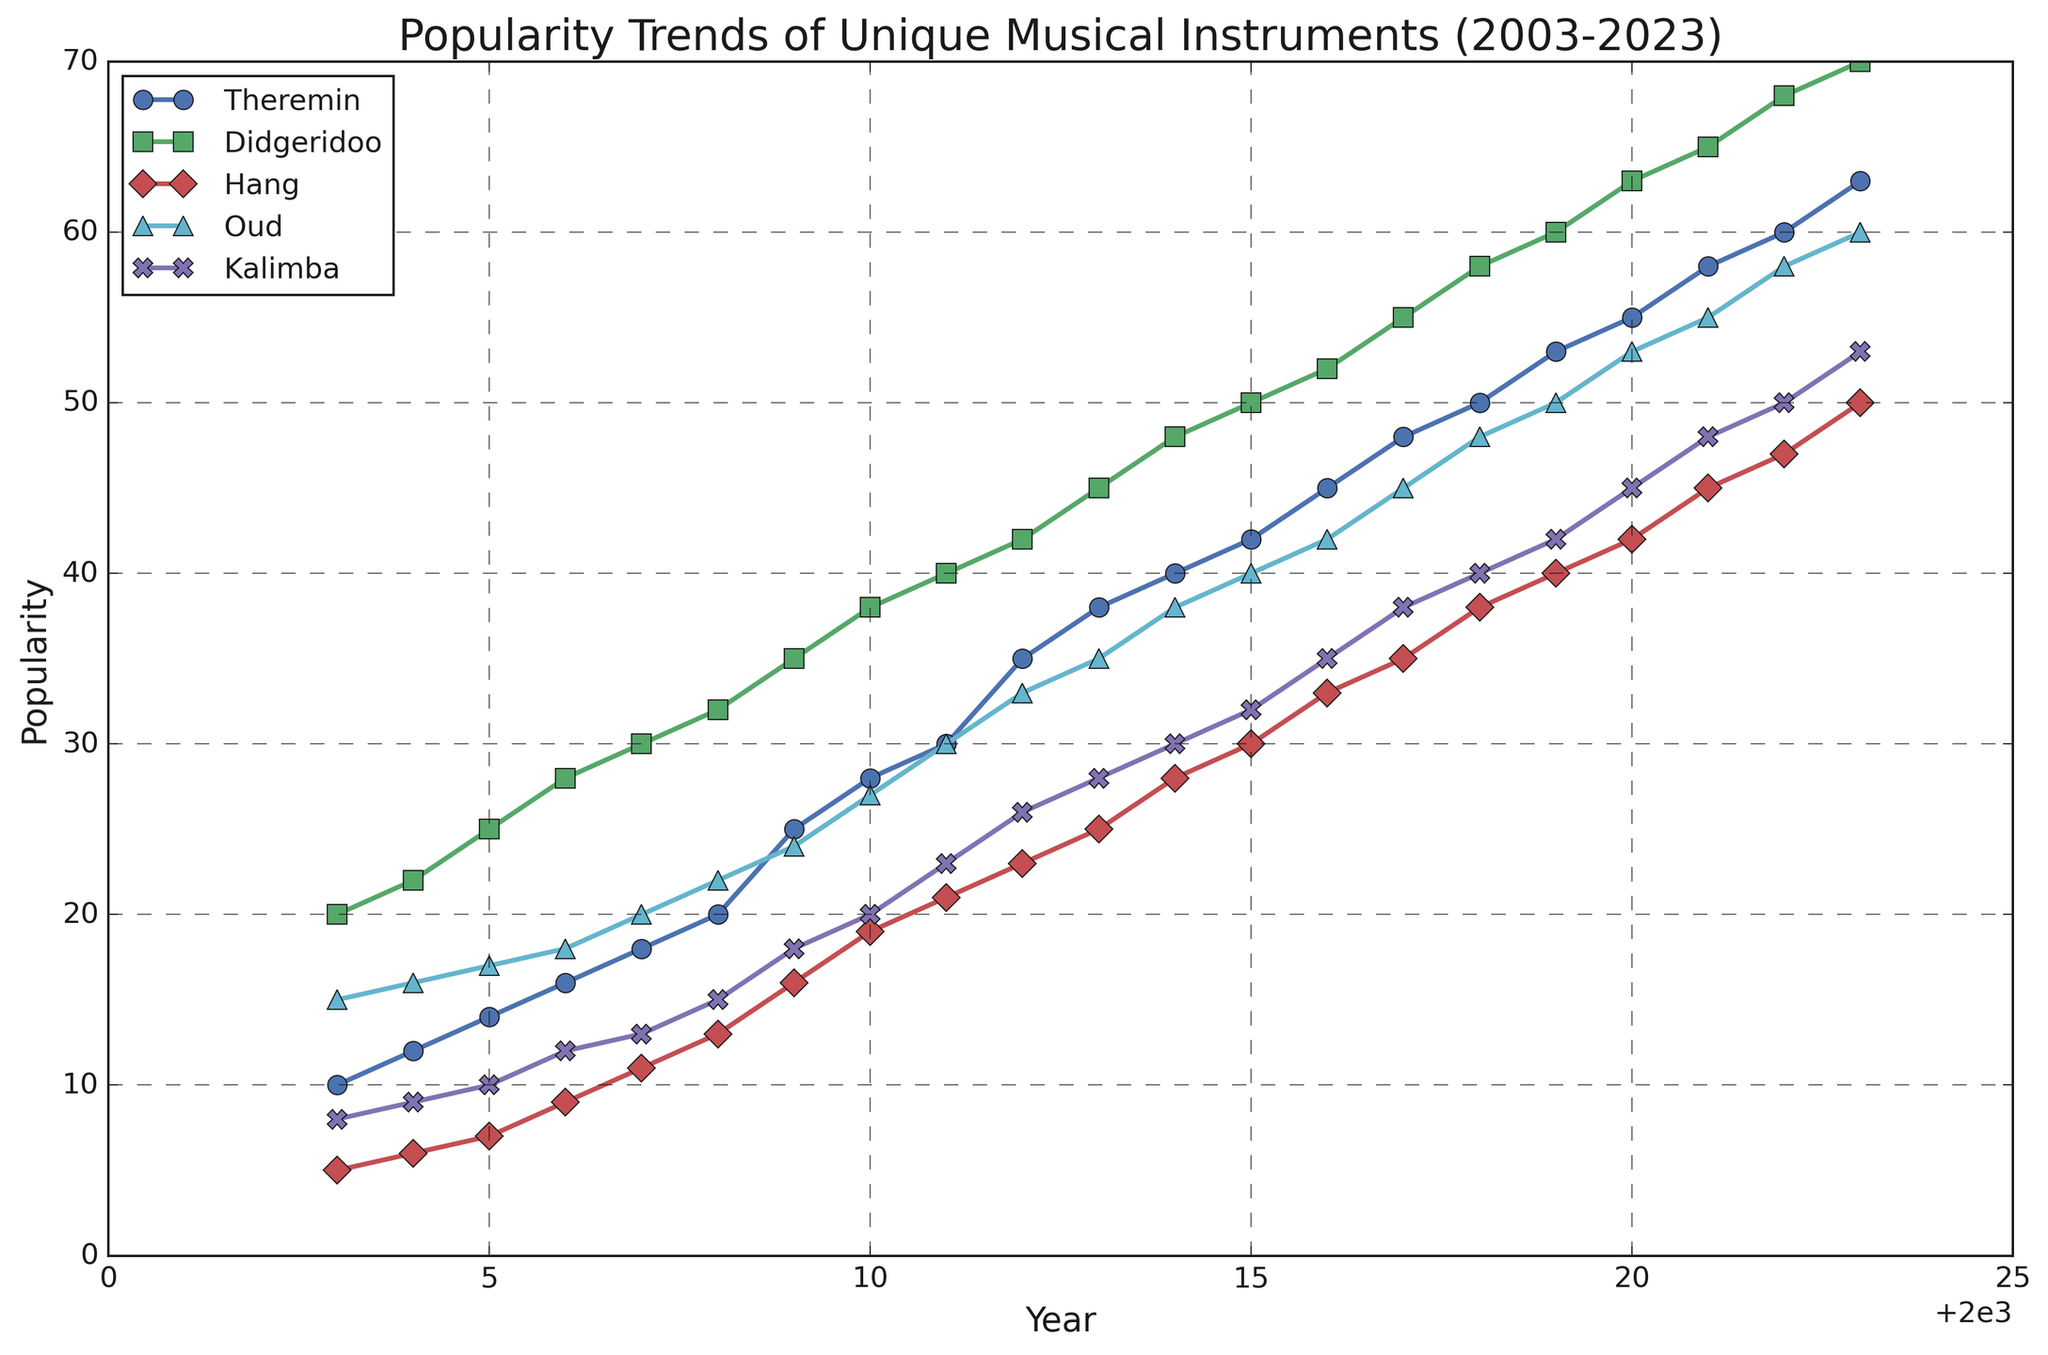What year did the Didgeridoo's popularity first surpass 50? The Didgeridoo's popularity is plotted in green with a line and square markers. By scanning for the value of 50 along this line, we see it is surpassed in 2015.
Answer: 2015 Which instrument shows the steepest increase in popularity over the 20-year period? To determine the steepest increase, we compare the slopes of the lines representing each instrument. The Theremin shows a steady rise, but the Didgeridoo climbs the highest, starting from 20 in 2003 to 70 in 2023, a net increase of 50 points.
Answer: Didgeridoo How much did the Oud's popularity grow between 2010 and 2020? By checking the blue line with triangle markers representing the Oud, we see the popularity in 2010 was 27 and in 2020 it was 53. The growth is 53 - 27.
Answer: 26 Which year did the Theremin and Hang cross paths in terms of popularity? The Theremin and Hang lines need to be compared visually to identify the crossing point. Around 2015, both lines appear to intersect where both reach popularity levels of 42 and 30 respectively.
Answer: 2015 What was the popularity trend for Kalimba from 2015 to 2023? Observing the purple line with X markers for Kalimba, from 2015 to 2023 the data shows a steady increase from 32 to 53.
Answer: Increasing What is the average popularity of the Hang in the first five years (2003-2007)? Adding the popularity scores of the Hang from 2003 to 2007 (5, 6, 7, 9, and 11) and then dividing by 5, the calculation is (5 + 6 + 7 + 9 + 11) / 5 which equals 7.6.
Answer: 7.6 Identify the year when Kalimba's popularity was equal to Hang's popularity. Tracking the purple and red lines (Kalimba and Hang respectively), the first equal point is in 2009 where both have a popularity score of 18.
Answer: 2009 Which instrument had the least popularity in 2023? By visually checking the endpoints of each colored line for the year 2023, the Hang (red line) has the lowest value at 50.
Answer: Hang Between which years did the Oud show the largest single-year increase in popularity? Observing the blue line marked by triangles representing Oud, the increase between 2021 and 2022 is from 55 to 58, which is the largest single jump in the period.
Answer: 2021-2022 How did the popularity of the Theremin compare to the Kalimba in 2012? In 2012, checking the green circles (Theremin) and the purple Xs (Kalimba), their popularity levels were 35 and 26 respectively. Thus, the Theremin was more popular.
Answer: Theremin was more popular 